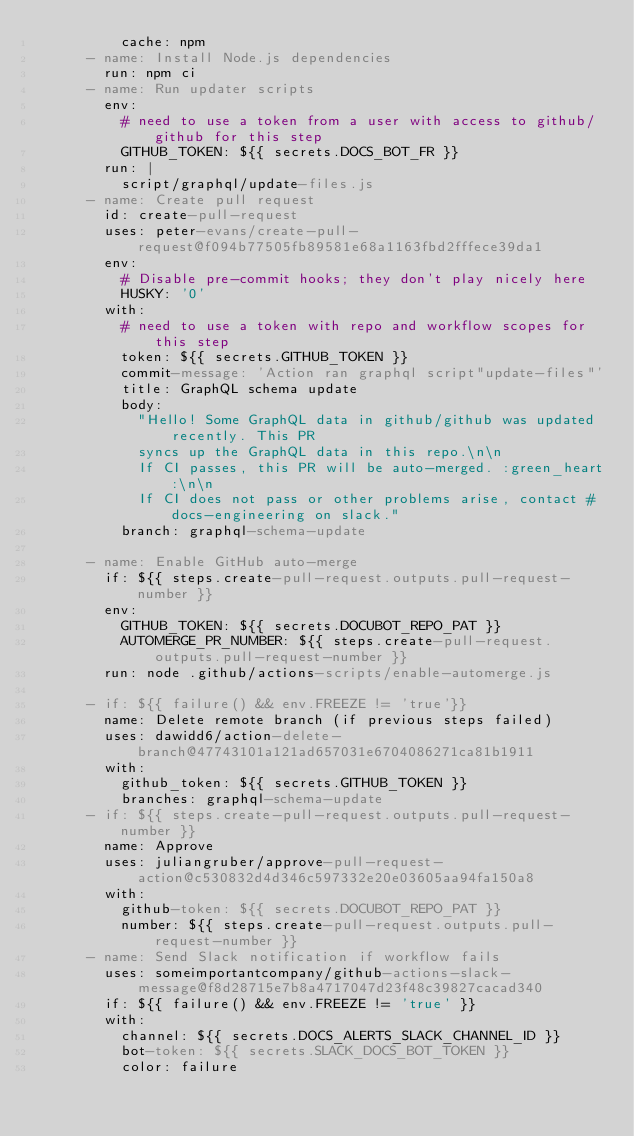<code> <loc_0><loc_0><loc_500><loc_500><_YAML_>          cache: npm
      - name: Install Node.js dependencies
        run: npm ci
      - name: Run updater scripts
        env:
          # need to use a token from a user with access to github/github for this step
          GITHUB_TOKEN: ${{ secrets.DOCS_BOT_FR }}
        run: |
          script/graphql/update-files.js
      - name: Create pull request
        id: create-pull-request
        uses: peter-evans/create-pull-request@f094b77505fb89581e68a1163fbd2fffece39da1
        env:
          # Disable pre-commit hooks; they don't play nicely here
          HUSKY: '0'
        with:
          # need to use a token with repo and workflow scopes for this step
          token: ${{ secrets.GITHUB_TOKEN }}
          commit-message: 'Action ran graphql script"update-files"'
          title: GraphQL schema update
          body:
            "Hello! Some GraphQL data in github/github was updated recently. This PR
            syncs up the GraphQL data in this repo.\n\n
            If CI passes, this PR will be auto-merged. :green_heart:\n\n
            If CI does not pass or other problems arise, contact #docs-engineering on slack."
          branch: graphql-schema-update

      - name: Enable GitHub auto-merge
        if: ${{ steps.create-pull-request.outputs.pull-request-number }}
        env:
          GITHUB_TOKEN: ${{ secrets.DOCUBOT_REPO_PAT }}
          AUTOMERGE_PR_NUMBER: ${{ steps.create-pull-request.outputs.pull-request-number }}
        run: node .github/actions-scripts/enable-automerge.js

      - if: ${{ failure() && env.FREEZE != 'true'}}
        name: Delete remote branch (if previous steps failed)
        uses: dawidd6/action-delete-branch@47743101a121ad657031e6704086271ca81b1911
        with:
          github_token: ${{ secrets.GITHUB_TOKEN }}
          branches: graphql-schema-update
      - if: ${{ steps.create-pull-request.outputs.pull-request-number }}
        name: Approve
        uses: juliangruber/approve-pull-request-action@c530832d4d346c597332e20e03605aa94fa150a8
        with:
          github-token: ${{ secrets.DOCUBOT_REPO_PAT }}
          number: ${{ steps.create-pull-request.outputs.pull-request-number }}
      - name: Send Slack notification if workflow fails
        uses: someimportantcompany/github-actions-slack-message@f8d28715e7b8a4717047d23f48c39827cacad340
        if: ${{ failure() && env.FREEZE != 'true' }}
        with:
          channel: ${{ secrets.DOCS_ALERTS_SLACK_CHANNEL_ID }}
          bot-token: ${{ secrets.SLACK_DOCS_BOT_TOKEN }}
          color: failure</code> 